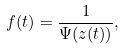<formula> <loc_0><loc_0><loc_500><loc_500>f ( t ) = \frac { 1 } { \Psi ( z ( t ) ) } ,</formula> 